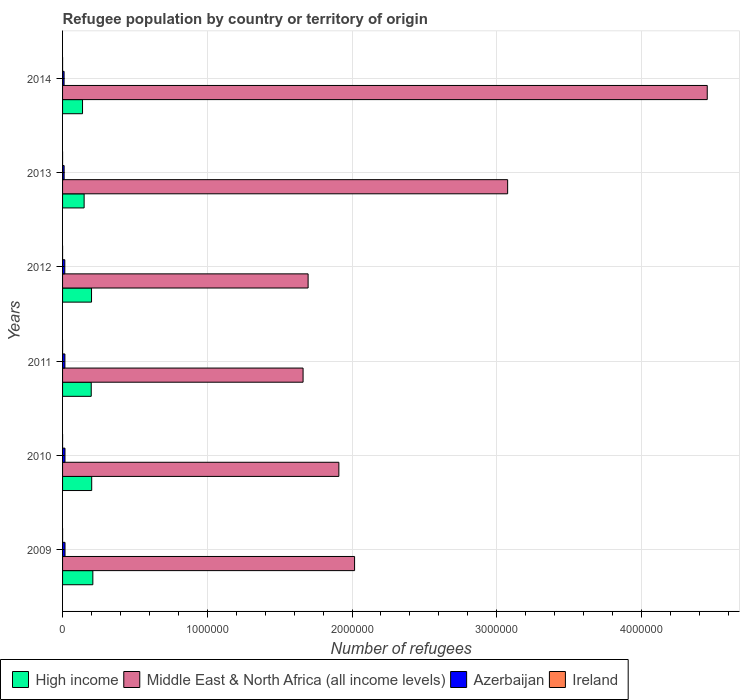Are the number of bars per tick equal to the number of legend labels?
Make the answer very short. Yes. What is the label of the 4th group of bars from the top?
Offer a terse response. 2011. In how many cases, is the number of bars for a given year not equal to the number of legend labels?
Give a very brief answer. 0. What is the number of refugees in Ireland in 2012?
Keep it short and to the point. 9. Across all years, what is the maximum number of refugees in Middle East & North Africa (all income levels)?
Offer a very short reply. 4.45e+06. Across all years, what is the minimum number of refugees in High income?
Provide a short and direct response. 1.38e+05. In which year was the number of refugees in Azerbaijan maximum?
Ensure brevity in your answer.  2009. In which year was the number of refugees in Middle East & North Africa (all income levels) minimum?
Make the answer very short. 2011. What is the total number of refugees in Middle East & North Africa (all income levels) in the graph?
Keep it short and to the point. 1.48e+07. What is the difference between the number of refugees in Azerbaijan in 2009 and that in 2014?
Keep it short and to the point. 6418. What is the difference between the number of refugees in High income in 2011 and the number of refugees in Middle East & North Africa (all income levels) in 2014?
Give a very brief answer. -4.26e+06. What is the average number of refugees in Middle East & North Africa (all income levels) per year?
Make the answer very short. 2.47e+06. In the year 2012, what is the difference between the number of refugees in Ireland and number of refugees in Azerbaijan?
Offer a very short reply. -1.55e+04. What is the ratio of the number of refugees in Middle East & North Africa (all income levels) in 2009 to that in 2014?
Your answer should be compact. 0.45. Is the number of refugees in Ireland in 2010 less than that in 2011?
Give a very brief answer. No. Is the difference between the number of refugees in Ireland in 2011 and 2012 greater than the difference between the number of refugees in Azerbaijan in 2011 and 2012?
Provide a short and direct response. No. What is the difference between the highest and the second highest number of refugees in High income?
Give a very brief answer. 7903. What is the difference between the highest and the lowest number of refugees in Middle East & North Africa (all income levels)?
Offer a terse response. 2.79e+06. Is it the case that in every year, the sum of the number of refugees in Middle East & North Africa (all income levels) and number of refugees in Ireland is greater than the sum of number of refugees in Azerbaijan and number of refugees in High income?
Offer a terse response. Yes. What does the 1st bar from the top in 2011 represents?
Provide a succinct answer. Ireland. What does the 1st bar from the bottom in 2009 represents?
Your answer should be very brief. High income. How many years are there in the graph?
Offer a very short reply. 6. Are the values on the major ticks of X-axis written in scientific E-notation?
Offer a terse response. No. Does the graph contain any zero values?
Provide a short and direct response. No. Does the graph contain grids?
Make the answer very short. Yes. How are the legend labels stacked?
Offer a very short reply. Horizontal. What is the title of the graph?
Give a very brief answer. Refugee population by country or territory of origin. What is the label or title of the X-axis?
Your answer should be compact. Number of refugees. What is the Number of refugees of High income in 2009?
Make the answer very short. 2.09e+05. What is the Number of refugees of Middle East & North Africa (all income levels) in 2009?
Make the answer very short. 2.02e+06. What is the Number of refugees in Azerbaijan in 2009?
Provide a short and direct response. 1.69e+04. What is the Number of refugees in High income in 2010?
Your response must be concise. 2.01e+05. What is the Number of refugees of Middle East & North Africa (all income levels) in 2010?
Provide a short and direct response. 1.91e+06. What is the Number of refugees in Azerbaijan in 2010?
Provide a short and direct response. 1.68e+04. What is the Number of refugees in Ireland in 2010?
Provide a succinct answer. 8. What is the Number of refugees in High income in 2011?
Your response must be concise. 1.98e+05. What is the Number of refugees in Middle East & North Africa (all income levels) in 2011?
Offer a terse response. 1.66e+06. What is the Number of refugees of Azerbaijan in 2011?
Make the answer very short. 1.62e+04. What is the Number of refugees in High income in 2012?
Offer a very short reply. 2.00e+05. What is the Number of refugees of Middle East & North Africa (all income levels) in 2012?
Your response must be concise. 1.70e+06. What is the Number of refugees in Azerbaijan in 2012?
Make the answer very short. 1.55e+04. What is the Number of refugees in Ireland in 2012?
Offer a terse response. 9. What is the Number of refugees of High income in 2013?
Offer a very short reply. 1.49e+05. What is the Number of refugees in Middle East & North Africa (all income levels) in 2013?
Give a very brief answer. 3.08e+06. What is the Number of refugees of Azerbaijan in 2013?
Offer a terse response. 1.08e+04. What is the Number of refugees in Ireland in 2013?
Keep it short and to the point. 9. What is the Number of refugees of High income in 2014?
Your answer should be compact. 1.38e+05. What is the Number of refugees in Middle East & North Africa (all income levels) in 2014?
Your answer should be very brief. 4.45e+06. What is the Number of refugees of Azerbaijan in 2014?
Provide a succinct answer. 1.05e+04. What is the Number of refugees of Ireland in 2014?
Offer a very short reply. 10. Across all years, what is the maximum Number of refugees of High income?
Make the answer very short. 2.09e+05. Across all years, what is the maximum Number of refugees of Middle East & North Africa (all income levels)?
Your answer should be very brief. 4.45e+06. Across all years, what is the maximum Number of refugees in Azerbaijan?
Keep it short and to the point. 1.69e+04. Across all years, what is the minimum Number of refugees in High income?
Give a very brief answer. 1.38e+05. Across all years, what is the minimum Number of refugees of Middle East & North Africa (all income levels)?
Offer a very short reply. 1.66e+06. Across all years, what is the minimum Number of refugees in Azerbaijan?
Your answer should be compact. 1.05e+04. Across all years, what is the minimum Number of refugees of Ireland?
Offer a very short reply. 7. What is the total Number of refugees in High income in the graph?
Provide a succinct answer. 1.10e+06. What is the total Number of refugees in Middle East & North Africa (all income levels) in the graph?
Your response must be concise. 1.48e+07. What is the total Number of refugees in Azerbaijan in the graph?
Your answer should be compact. 8.67e+04. What is the difference between the Number of refugees in High income in 2009 and that in 2010?
Give a very brief answer. 7903. What is the difference between the Number of refugees of Middle East & North Africa (all income levels) in 2009 and that in 2010?
Your response must be concise. 1.09e+05. What is the difference between the Number of refugees of Azerbaijan in 2009 and that in 2010?
Your response must be concise. 186. What is the difference between the Number of refugees of High income in 2009 and that in 2011?
Ensure brevity in your answer.  1.12e+04. What is the difference between the Number of refugees of Middle East & North Africa (all income levels) in 2009 and that in 2011?
Your response must be concise. 3.56e+05. What is the difference between the Number of refugees of Azerbaijan in 2009 and that in 2011?
Ensure brevity in your answer.  777. What is the difference between the Number of refugees of High income in 2009 and that in 2012?
Give a very brief answer. 9070. What is the difference between the Number of refugees of Middle East & North Africa (all income levels) in 2009 and that in 2012?
Give a very brief answer. 3.21e+05. What is the difference between the Number of refugees in Azerbaijan in 2009 and that in 2012?
Ensure brevity in your answer.  1402. What is the difference between the Number of refugees of High income in 2009 and that in 2013?
Your answer should be very brief. 6.02e+04. What is the difference between the Number of refugees in Middle East & North Africa (all income levels) in 2009 and that in 2013?
Your response must be concise. -1.06e+06. What is the difference between the Number of refugees of Azerbaijan in 2009 and that in 2013?
Provide a short and direct response. 6126. What is the difference between the Number of refugees in Ireland in 2009 and that in 2013?
Provide a succinct answer. -2. What is the difference between the Number of refugees of High income in 2009 and that in 2014?
Ensure brevity in your answer.  7.13e+04. What is the difference between the Number of refugees in Middle East & North Africa (all income levels) in 2009 and that in 2014?
Your answer should be very brief. -2.44e+06. What is the difference between the Number of refugees of Azerbaijan in 2009 and that in 2014?
Provide a short and direct response. 6418. What is the difference between the Number of refugees of High income in 2010 and that in 2011?
Make the answer very short. 3264. What is the difference between the Number of refugees in Middle East & North Africa (all income levels) in 2010 and that in 2011?
Provide a succinct answer. 2.47e+05. What is the difference between the Number of refugees of Azerbaijan in 2010 and that in 2011?
Make the answer very short. 591. What is the difference between the Number of refugees of High income in 2010 and that in 2012?
Your response must be concise. 1167. What is the difference between the Number of refugees of Middle East & North Africa (all income levels) in 2010 and that in 2012?
Make the answer very short. 2.12e+05. What is the difference between the Number of refugees in Azerbaijan in 2010 and that in 2012?
Provide a short and direct response. 1216. What is the difference between the Number of refugees of Ireland in 2010 and that in 2012?
Keep it short and to the point. -1. What is the difference between the Number of refugees in High income in 2010 and that in 2013?
Your answer should be very brief. 5.23e+04. What is the difference between the Number of refugees in Middle East & North Africa (all income levels) in 2010 and that in 2013?
Offer a terse response. -1.17e+06. What is the difference between the Number of refugees of Azerbaijan in 2010 and that in 2013?
Your response must be concise. 5940. What is the difference between the Number of refugees in Ireland in 2010 and that in 2013?
Ensure brevity in your answer.  -1. What is the difference between the Number of refugees in High income in 2010 and that in 2014?
Provide a short and direct response. 6.34e+04. What is the difference between the Number of refugees of Middle East & North Africa (all income levels) in 2010 and that in 2014?
Give a very brief answer. -2.55e+06. What is the difference between the Number of refugees of Azerbaijan in 2010 and that in 2014?
Your answer should be compact. 6232. What is the difference between the Number of refugees of Ireland in 2010 and that in 2014?
Give a very brief answer. -2. What is the difference between the Number of refugees in High income in 2011 and that in 2012?
Offer a very short reply. -2097. What is the difference between the Number of refugees of Middle East & North Africa (all income levels) in 2011 and that in 2012?
Make the answer very short. -3.48e+04. What is the difference between the Number of refugees of Azerbaijan in 2011 and that in 2012?
Provide a succinct answer. 625. What is the difference between the Number of refugees in Ireland in 2011 and that in 2012?
Your response must be concise. -1. What is the difference between the Number of refugees of High income in 2011 and that in 2013?
Offer a terse response. 4.90e+04. What is the difference between the Number of refugees in Middle East & North Africa (all income levels) in 2011 and that in 2013?
Your answer should be very brief. -1.41e+06. What is the difference between the Number of refugees in Azerbaijan in 2011 and that in 2013?
Provide a short and direct response. 5349. What is the difference between the Number of refugees in High income in 2011 and that in 2014?
Your answer should be very brief. 6.01e+04. What is the difference between the Number of refugees of Middle East & North Africa (all income levels) in 2011 and that in 2014?
Make the answer very short. -2.79e+06. What is the difference between the Number of refugees in Azerbaijan in 2011 and that in 2014?
Ensure brevity in your answer.  5641. What is the difference between the Number of refugees of High income in 2012 and that in 2013?
Offer a very short reply. 5.11e+04. What is the difference between the Number of refugees in Middle East & North Africa (all income levels) in 2012 and that in 2013?
Provide a short and direct response. -1.38e+06. What is the difference between the Number of refugees of Azerbaijan in 2012 and that in 2013?
Keep it short and to the point. 4724. What is the difference between the Number of refugees in Ireland in 2012 and that in 2013?
Keep it short and to the point. 0. What is the difference between the Number of refugees of High income in 2012 and that in 2014?
Make the answer very short. 6.22e+04. What is the difference between the Number of refugees in Middle East & North Africa (all income levels) in 2012 and that in 2014?
Ensure brevity in your answer.  -2.76e+06. What is the difference between the Number of refugees of Azerbaijan in 2012 and that in 2014?
Offer a terse response. 5016. What is the difference between the Number of refugees of High income in 2013 and that in 2014?
Your answer should be very brief. 1.11e+04. What is the difference between the Number of refugees in Middle East & North Africa (all income levels) in 2013 and that in 2014?
Keep it short and to the point. -1.38e+06. What is the difference between the Number of refugees in Azerbaijan in 2013 and that in 2014?
Your response must be concise. 292. What is the difference between the Number of refugees of Ireland in 2013 and that in 2014?
Your response must be concise. -1. What is the difference between the Number of refugees of High income in 2009 and the Number of refugees of Middle East & North Africa (all income levels) in 2010?
Your response must be concise. -1.70e+06. What is the difference between the Number of refugees in High income in 2009 and the Number of refugees in Azerbaijan in 2010?
Provide a short and direct response. 1.92e+05. What is the difference between the Number of refugees of High income in 2009 and the Number of refugees of Ireland in 2010?
Your answer should be very brief. 2.09e+05. What is the difference between the Number of refugees of Middle East & North Africa (all income levels) in 2009 and the Number of refugees of Azerbaijan in 2010?
Offer a terse response. 2.00e+06. What is the difference between the Number of refugees in Middle East & North Africa (all income levels) in 2009 and the Number of refugees in Ireland in 2010?
Your answer should be compact. 2.02e+06. What is the difference between the Number of refugees of Azerbaijan in 2009 and the Number of refugees of Ireland in 2010?
Give a very brief answer. 1.69e+04. What is the difference between the Number of refugees in High income in 2009 and the Number of refugees in Middle East & North Africa (all income levels) in 2011?
Your answer should be very brief. -1.45e+06. What is the difference between the Number of refugees of High income in 2009 and the Number of refugees of Azerbaijan in 2011?
Offer a very short reply. 1.93e+05. What is the difference between the Number of refugees in High income in 2009 and the Number of refugees in Ireland in 2011?
Keep it short and to the point. 2.09e+05. What is the difference between the Number of refugees in Middle East & North Africa (all income levels) in 2009 and the Number of refugees in Azerbaijan in 2011?
Provide a succinct answer. 2.00e+06. What is the difference between the Number of refugees of Middle East & North Africa (all income levels) in 2009 and the Number of refugees of Ireland in 2011?
Provide a succinct answer. 2.02e+06. What is the difference between the Number of refugees of Azerbaijan in 2009 and the Number of refugees of Ireland in 2011?
Your answer should be compact. 1.69e+04. What is the difference between the Number of refugees of High income in 2009 and the Number of refugees of Middle East & North Africa (all income levels) in 2012?
Provide a succinct answer. -1.49e+06. What is the difference between the Number of refugees of High income in 2009 and the Number of refugees of Azerbaijan in 2012?
Ensure brevity in your answer.  1.94e+05. What is the difference between the Number of refugees in High income in 2009 and the Number of refugees in Ireland in 2012?
Your answer should be very brief. 2.09e+05. What is the difference between the Number of refugees in Middle East & North Africa (all income levels) in 2009 and the Number of refugees in Azerbaijan in 2012?
Keep it short and to the point. 2.00e+06. What is the difference between the Number of refugees in Middle East & North Africa (all income levels) in 2009 and the Number of refugees in Ireland in 2012?
Your response must be concise. 2.02e+06. What is the difference between the Number of refugees in Azerbaijan in 2009 and the Number of refugees in Ireland in 2012?
Make the answer very short. 1.69e+04. What is the difference between the Number of refugees in High income in 2009 and the Number of refugees in Middle East & North Africa (all income levels) in 2013?
Offer a very short reply. -2.87e+06. What is the difference between the Number of refugees in High income in 2009 and the Number of refugees in Azerbaijan in 2013?
Your answer should be very brief. 1.98e+05. What is the difference between the Number of refugees of High income in 2009 and the Number of refugees of Ireland in 2013?
Offer a very short reply. 2.09e+05. What is the difference between the Number of refugees in Middle East & North Africa (all income levels) in 2009 and the Number of refugees in Azerbaijan in 2013?
Ensure brevity in your answer.  2.01e+06. What is the difference between the Number of refugees in Middle East & North Africa (all income levels) in 2009 and the Number of refugees in Ireland in 2013?
Provide a short and direct response. 2.02e+06. What is the difference between the Number of refugees of Azerbaijan in 2009 and the Number of refugees of Ireland in 2013?
Ensure brevity in your answer.  1.69e+04. What is the difference between the Number of refugees in High income in 2009 and the Number of refugees in Middle East & North Africa (all income levels) in 2014?
Your answer should be compact. -4.25e+06. What is the difference between the Number of refugees in High income in 2009 and the Number of refugees in Azerbaijan in 2014?
Offer a very short reply. 1.99e+05. What is the difference between the Number of refugees of High income in 2009 and the Number of refugees of Ireland in 2014?
Your response must be concise. 2.09e+05. What is the difference between the Number of refugees in Middle East & North Africa (all income levels) in 2009 and the Number of refugees in Azerbaijan in 2014?
Keep it short and to the point. 2.01e+06. What is the difference between the Number of refugees in Middle East & North Africa (all income levels) in 2009 and the Number of refugees in Ireland in 2014?
Keep it short and to the point. 2.02e+06. What is the difference between the Number of refugees in Azerbaijan in 2009 and the Number of refugees in Ireland in 2014?
Your answer should be compact. 1.69e+04. What is the difference between the Number of refugees in High income in 2010 and the Number of refugees in Middle East & North Africa (all income levels) in 2011?
Provide a succinct answer. -1.46e+06. What is the difference between the Number of refugees in High income in 2010 and the Number of refugees in Azerbaijan in 2011?
Provide a succinct answer. 1.85e+05. What is the difference between the Number of refugees in High income in 2010 and the Number of refugees in Ireland in 2011?
Your answer should be compact. 2.01e+05. What is the difference between the Number of refugees of Middle East & North Africa (all income levels) in 2010 and the Number of refugees of Azerbaijan in 2011?
Make the answer very short. 1.89e+06. What is the difference between the Number of refugees of Middle East & North Africa (all income levels) in 2010 and the Number of refugees of Ireland in 2011?
Your answer should be very brief. 1.91e+06. What is the difference between the Number of refugees in Azerbaijan in 2010 and the Number of refugees in Ireland in 2011?
Provide a succinct answer. 1.67e+04. What is the difference between the Number of refugees of High income in 2010 and the Number of refugees of Middle East & North Africa (all income levels) in 2012?
Your answer should be compact. -1.50e+06. What is the difference between the Number of refugees in High income in 2010 and the Number of refugees in Azerbaijan in 2012?
Your answer should be very brief. 1.86e+05. What is the difference between the Number of refugees of High income in 2010 and the Number of refugees of Ireland in 2012?
Give a very brief answer. 2.01e+05. What is the difference between the Number of refugees of Middle East & North Africa (all income levels) in 2010 and the Number of refugees of Azerbaijan in 2012?
Offer a terse response. 1.89e+06. What is the difference between the Number of refugees of Middle East & North Africa (all income levels) in 2010 and the Number of refugees of Ireland in 2012?
Ensure brevity in your answer.  1.91e+06. What is the difference between the Number of refugees of Azerbaijan in 2010 and the Number of refugees of Ireland in 2012?
Offer a very short reply. 1.67e+04. What is the difference between the Number of refugees in High income in 2010 and the Number of refugees in Middle East & North Africa (all income levels) in 2013?
Your answer should be very brief. -2.87e+06. What is the difference between the Number of refugees of High income in 2010 and the Number of refugees of Azerbaijan in 2013?
Your response must be concise. 1.90e+05. What is the difference between the Number of refugees in High income in 2010 and the Number of refugees in Ireland in 2013?
Ensure brevity in your answer.  2.01e+05. What is the difference between the Number of refugees in Middle East & North Africa (all income levels) in 2010 and the Number of refugees in Azerbaijan in 2013?
Your response must be concise. 1.90e+06. What is the difference between the Number of refugees in Middle East & North Africa (all income levels) in 2010 and the Number of refugees in Ireland in 2013?
Offer a very short reply. 1.91e+06. What is the difference between the Number of refugees of Azerbaijan in 2010 and the Number of refugees of Ireland in 2013?
Your answer should be compact. 1.67e+04. What is the difference between the Number of refugees in High income in 2010 and the Number of refugees in Middle East & North Africa (all income levels) in 2014?
Provide a succinct answer. -4.25e+06. What is the difference between the Number of refugees of High income in 2010 and the Number of refugees of Azerbaijan in 2014?
Ensure brevity in your answer.  1.91e+05. What is the difference between the Number of refugees in High income in 2010 and the Number of refugees in Ireland in 2014?
Provide a succinct answer. 2.01e+05. What is the difference between the Number of refugees in Middle East & North Africa (all income levels) in 2010 and the Number of refugees in Azerbaijan in 2014?
Your answer should be compact. 1.90e+06. What is the difference between the Number of refugees of Middle East & North Africa (all income levels) in 2010 and the Number of refugees of Ireland in 2014?
Ensure brevity in your answer.  1.91e+06. What is the difference between the Number of refugees in Azerbaijan in 2010 and the Number of refugees in Ireland in 2014?
Your response must be concise. 1.67e+04. What is the difference between the Number of refugees of High income in 2011 and the Number of refugees of Middle East & North Africa (all income levels) in 2012?
Give a very brief answer. -1.50e+06. What is the difference between the Number of refugees of High income in 2011 and the Number of refugees of Azerbaijan in 2012?
Offer a very short reply. 1.82e+05. What is the difference between the Number of refugees in High income in 2011 and the Number of refugees in Ireland in 2012?
Your answer should be very brief. 1.98e+05. What is the difference between the Number of refugees of Middle East & North Africa (all income levels) in 2011 and the Number of refugees of Azerbaijan in 2012?
Offer a very short reply. 1.65e+06. What is the difference between the Number of refugees in Middle East & North Africa (all income levels) in 2011 and the Number of refugees in Ireland in 2012?
Your answer should be compact. 1.66e+06. What is the difference between the Number of refugees of Azerbaijan in 2011 and the Number of refugees of Ireland in 2012?
Keep it short and to the point. 1.62e+04. What is the difference between the Number of refugees in High income in 2011 and the Number of refugees in Middle East & North Africa (all income levels) in 2013?
Ensure brevity in your answer.  -2.88e+06. What is the difference between the Number of refugees of High income in 2011 and the Number of refugees of Azerbaijan in 2013?
Keep it short and to the point. 1.87e+05. What is the difference between the Number of refugees of High income in 2011 and the Number of refugees of Ireland in 2013?
Make the answer very short. 1.98e+05. What is the difference between the Number of refugees in Middle East & North Africa (all income levels) in 2011 and the Number of refugees in Azerbaijan in 2013?
Offer a terse response. 1.65e+06. What is the difference between the Number of refugees of Middle East & North Africa (all income levels) in 2011 and the Number of refugees of Ireland in 2013?
Provide a succinct answer. 1.66e+06. What is the difference between the Number of refugees of Azerbaijan in 2011 and the Number of refugees of Ireland in 2013?
Ensure brevity in your answer.  1.62e+04. What is the difference between the Number of refugees of High income in 2011 and the Number of refugees of Middle East & North Africa (all income levels) in 2014?
Ensure brevity in your answer.  -4.26e+06. What is the difference between the Number of refugees in High income in 2011 and the Number of refugees in Azerbaijan in 2014?
Make the answer very short. 1.88e+05. What is the difference between the Number of refugees of High income in 2011 and the Number of refugees of Ireland in 2014?
Give a very brief answer. 1.98e+05. What is the difference between the Number of refugees in Middle East & North Africa (all income levels) in 2011 and the Number of refugees in Azerbaijan in 2014?
Ensure brevity in your answer.  1.65e+06. What is the difference between the Number of refugees of Middle East & North Africa (all income levels) in 2011 and the Number of refugees of Ireland in 2014?
Your answer should be very brief. 1.66e+06. What is the difference between the Number of refugees in Azerbaijan in 2011 and the Number of refugees in Ireland in 2014?
Make the answer very short. 1.62e+04. What is the difference between the Number of refugees of High income in 2012 and the Number of refugees of Middle East & North Africa (all income levels) in 2013?
Give a very brief answer. -2.87e+06. What is the difference between the Number of refugees in High income in 2012 and the Number of refugees in Azerbaijan in 2013?
Keep it short and to the point. 1.89e+05. What is the difference between the Number of refugees in High income in 2012 and the Number of refugees in Ireland in 2013?
Offer a terse response. 2.00e+05. What is the difference between the Number of refugees in Middle East & North Africa (all income levels) in 2012 and the Number of refugees in Azerbaijan in 2013?
Offer a very short reply. 1.69e+06. What is the difference between the Number of refugees in Middle East & North Africa (all income levels) in 2012 and the Number of refugees in Ireland in 2013?
Make the answer very short. 1.70e+06. What is the difference between the Number of refugees in Azerbaijan in 2012 and the Number of refugees in Ireland in 2013?
Offer a very short reply. 1.55e+04. What is the difference between the Number of refugees in High income in 2012 and the Number of refugees in Middle East & North Africa (all income levels) in 2014?
Give a very brief answer. -4.25e+06. What is the difference between the Number of refugees in High income in 2012 and the Number of refugees in Azerbaijan in 2014?
Give a very brief answer. 1.90e+05. What is the difference between the Number of refugees of High income in 2012 and the Number of refugees of Ireland in 2014?
Provide a succinct answer. 2.00e+05. What is the difference between the Number of refugees of Middle East & North Africa (all income levels) in 2012 and the Number of refugees of Azerbaijan in 2014?
Your answer should be very brief. 1.69e+06. What is the difference between the Number of refugees in Middle East & North Africa (all income levels) in 2012 and the Number of refugees in Ireland in 2014?
Offer a very short reply. 1.70e+06. What is the difference between the Number of refugees of Azerbaijan in 2012 and the Number of refugees of Ireland in 2014?
Ensure brevity in your answer.  1.55e+04. What is the difference between the Number of refugees of High income in 2013 and the Number of refugees of Middle East & North Africa (all income levels) in 2014?
Offer a terse response. -4.31e+06. What is the difference between the Number of refugees of High income in 2013 and the Number of refugees of Azerbaijan in 2014?
Ensure brevity in your answer.  1.38e+05. What is the difference between the Number of refugees in High income in 2013 and the Number of refugees in Ireland in 2014?
Your response must be concise. 1.49e+05. What is the difference between the Number of refugees of Middle East & North Africa (all income levels) in 2013 and the Number of refugees of Azerbaijan in 2014?
Offer a very short reply. 3.06e+06. What is the difference between the Number of refugees in Middle East & North Africa (all income levels) in 2013 and the Number of refugees in Ireland in 2014?
Ensure brevity in your answer.  3.08e+06. What is the difference between the Number of refugees in Azerbaijan in 2013 and the Number of refugees in Ireland in 2014?
Give a very brief answer. 1.08e+04. What is the average Number of refugees in High income per year?
Your answer should be compact. 1.83e+05. What is the average Number of refugees of Middle East & North Africa (all income levels) per year?
Your answer should be compact. 2.47e+06. What is the average Number of refugees of Azerbaijan per year?
Your answer should be compact. 1.45e+04. In the year 2009, what is the difference between the Number of refugees in High income and Number of refugees in Middle East & North Africa (all income levels)?
Offer a terse response. -1.81e+06. In the year 2009, what is the difference between the Number of refugees in High income and Number of refugees in Azerbaijan?
Offer a very short reply. 1.92e+05. In the year 2009, what is the difference between the Number of refugees in High income and Number of refugees in Ireland?
Your answer should be very brief. 2.09e+05. In the year 2009, what is the difference between the Number of refugees in Middle East & North Africa (all income levels) and Number of refugees in Azerbaijan?
Provide a short and direct response. 2.00e+06. In the year 2009, what is the difference between the Number of refugees in Middle East & North Africa (all income levels) and Number of refugees in Ireland?
Your answer should be very brief. 2.02e+06. In the year 2009, what is the difference between the Number of refugees of Azerbaijan and Number of refugees of Ireland?
Your response must be concise. 1.69e+04. In the year 2010, what is the difference between the Number of refugees in High income and Number of refugees in Middle East & North Africa (all income levels)?
Provide a succinct answer. -1.71e+06. In the year 2010, what is the difference between the Number of refugees of High income and Number of refugees of Azerbaijan?
Provide a short and direct response. 1.85e+05. In the year 2010, what is the difference between the Number of refugees of High income and Number of refugees of Ireland?
Make the answer very short. 2.01e+05. In the year 2010, what is the difference between the Number of refugees of Middle East & North Africa (all income levels) and Number of refugees of Azerbaijan?
Your answer should be compact. 1.89e+06. In the year 2010, what is the difference between the Number of refugees in Middle East & North Africa (all income levels) and Number of refugees in Ireland?
Your answer should be compact. 1.91e+06. In the year 2010, what is the difference between the Number of refugees in Azerbaijan and Number of refugees in Ireland?
Offer a very short reply. 1.67e+04. In the year 2011, what is the difference between the Number of refugees of High income and Number of refugees of Middle East & North Africa (all income levels)?
Your answer should be very brief. -1.46e+06. In the year 2011, what is the difference between the Number of refugees in High income and Number of refugees in Azerbaijan?
Make the answer very short. 1.82e+05. In the year 2011, what is the difference between the Number of refugees of High income and Number of refugees of Ireland?
Keep it short and to the point. 1.98e+05. In the year 2011, what is the difference between the Number of refugees in Middle East & North Africa (all income levels) and Number of refugees in Azerbaijan?
Give a very brief answer. 1.65e+06. In the year 2011, what is the difference between the Number of refugees in Middle East & North Africa (all income levels) and Number of refugees in Ireland?
Give a very brief answer. 1.66e+06. In the year 2011, what is the difference between the Number of refugees in Azerbaijan and Number of refugees in Ireland?
Your answer should be very brief. 1.62e+04. In the year 2012, what is the difference between the Number of refugees of High income and Number of refugees of Middle East & North Africa (all income levels)?
Ensure brevity in your answer.  -1.50e+06. In the year 2012, what is the difference between the Number of refugees in High income and Number of refugees in Azerbaijan?
Make the answer very short. 1.85e+05. In the year 2012, what is the difference between the Number of refugees in High income and Number of refugees in Ireland?
Your response must be concise. 2.00e+05. In the year 2012, what is the difference between the Number of refugees in Middle East & North Africa (all income levels) and Number of refugees in Azerbaijan?
Offer a very short reply. 1.68e+06. In the year 2012, what is the difference between the Number of refugees in Middle East & North Africa (all income levels) and Number of refugees in Ireland?
Your response must be concise. 1.70e+06. In the year 2012, what is the difference between the Number of refugees of Azerbaijan and Number of refugees of Ireland?
Your response must be concise. 1.55e+04. In the year 2013, what is the difference between the Number of refugees in High income and Number of refugees in Middle East & North Africa (all income levels)?
Your response must be concise. -2.93e+06. In the year 2013, what is the difference between the Number of refugees in High income and Number of refugees in Azerbaijan?
Offer a terse response. 1.38e+05. In the year 2013, what is the difference between the Number of refugees in High income and Number of refugees in Ireland?
Give a very brief answer. 1.49e+05. In the year 2013, what is the difference between the Number of refugees in Middle East & North Africa (all income levels) and Number of refugees in Azerbaijan?
Your response must be concise. 3.06e+06. In the year 2013, what is the difference between the Number of refugees of Middle East & North Africa (all income levels) and Number of refugees of Ireland?
Provide a succinct answer. 3.08e+06. In the year 2013, what is the difference between the Number of refugees in Azerbaijan and Number of refugees in Ireland?
Your answer should be very brief. 1.08e+04. In the year 2014, what is the difference between the Number of refugees of High income and Number of refugees of Middle East & North Africa (all income levels)?
Offer a terse response. -4.32e+06. In the year 2014, what is the difference between the Number of refugees in High income and Number of refugees in Azerbaijan?
Ensure brevity in your answer.  1.27e+05. In the year 2014, what is the difference between the Number of refugees in High income and Number of refugees in Ireland?
Offer a very short reply. 1.38e+05. In the year 2014, what is the difference between the Number of refugees of Middle East & North Africa (all income levels) and Number of refugees of Azerbaijan?
Your answer should be very brief. 4.44e+06. In the year 2014, what is the difference between the Number of refugees in Middle East & North Africa (all income levels) and Number of refugees in Ireland?
Your response must be concise. 4.45e+06. In the year 2014, what is the difference between the Number of refugees in Azerbaijan and Number of refugees in Ireland?
Keep it short and to the point. 1.05e+04. What is the ratio of the Number of refugees in High income in 2009 to that in 2010?
Ensure brevity in your answer.  1.04. What is the ratio of the Number of refugees in Middle East & North Africa (all income levels) in 2009 to that in 2010?
Offer a terse response. 1.06. What is the ratio of the Number of refugees in Azerbaijan in 2009 to that in 2010?
Make the answer very short. 1.01. What is the ratio of the Number of refugees in Ireland in 2009 to that in 2010?
Your answer should be very brief. 0.88. What is the ratio of the Number of refugees in High income in 2009 to that in 2011?
Your response must be concise. 1.06. What is the ratio of the Number of refugees of Middle East & North Africa (all income levels) in 2009 to that in 2011?
Your answer should be very brief. 1.21. What is the ratio of the Number of refugees in Azerbaijan in 2009 to that in 2011?
Offer a terse response. 1.05. What is the ratio of the Number of refugees of High income in 2009 to that in 2012?
Provide a short and direct response. 1.05. What is the ratio of the Number of refugees in Middle East & North Africa (all income levels) in 2009 to that in 2012?
Your answer should be compact. 1.19. What is the ratio of the Number of refugees of Azerbaijan in 2009 to that in 2012?
Keep it short and to the point. 1.09. What is the ratio of the Number of refugees in Ireland in 2009 to that in 2012?
Keep it short and to the point. 0.78. What is the ratio of the Number of refugees of High income in 2009 to that in 2013?
Offer a terse response. 1.4. What is the ratio of the Number of refugees in Middle East & North Africa (all income levels) in 2009 to that in 2013?
Your response must be concise. 0.66. What is the ratio of the Number of refugees of Azerbaijan in 2009 to that in 2013?
Offer a very short reply. 1.57. What is the ratio of the Number of refugees in Ireland in 2009 to that in 2013?
Offer a very short reply. 0.78. What is the ratio of the Number of refugees of High income in 2009 to that in 2014?
Ensure brevity in your answer.  1.52. What is the ratio of the Number of refugees of Middle East & North Africa (all income levels) in 2009 to that in 2014?
Give a very brief answer. 0.45. What is the ratio of the Number of refugees in Azerbaijan in 2009 to that in 2014?
Ensure brevity in your answer.  1.61. What is the ratio of the Number of refugees of High income in 2010 to that in 2011?
Keep it short and to the point. 1.02. What is the ratio of the Number of refugees in Middle East & North Africa (all income levels) in 2010 to that in 2011?
Ensure brevity in your answer.  1.15. What is the ratio of the Number of refugees in Azerbaijan in 2010 to that in 2011?
Your answer should be very brief. 1.04. What is the ratio of the Number of refugees of Middle East & North Africa (all income levels) in 2010 to that in 2012?
Your answer should be compact. 1.13. What is the ratio of the Number of refugees of Azerbaijan in 2010 to that in 2012?
Make the answer very short. 1.08. What is the ratio of the Number of refugees of High income in 2010 to that in 2013?
Your response must be concise. 1.35. What is the ratio of the Number of refugees in Middle East & North Africa (all income levels) in 2010 to that in 2013?
Provide a succinct answer. 0.62. What is the ratio of the Number of refugees in Azerbaijan in 2010 to that in 2013?
Offer a terse response. 1.55. What is the ratio of the Number of refugees of Ireland in 2010 to that in 2013?
Ensure brevity in your answer.  0.89. What is the ratio of the Number of refugees of High income in 2010 to that in 2014?
Offer a terse response. 1.46. What is the ratio of the Number of refugees of Middle East & North Africa (all income levels) in 2010 to that in 2014?
Provide a short and direct response. 0.43. What is the ratio of the Number of refugees of Azerbaijan in 2010 to that in 2014?
Offer a very short reply. 1.59. What is the ratio of the Number of refugees in Middle East & North Africa (all income levels) in 2011 to that in 2012?
Your response must be concise. 0.98. What is the ratio of the Number of refugees in Azerbaijan in 2011 to that in 2012?
Offer a terse response. 1.04. What is the ratio of the Number of refugees of Ireland in 2011 to that in 2012?
Your answer should be compact. 0.89. What is the ratio of the Number of refugees in High income in 2011 to that in 2013?
Provide a succinct answer. 1.33. What is the ratio of the Number of refugees of Middle East & North Africa (all income levels) in 2011 to that in 2013?
Provide a succinct answer. 0.54. What is the ratio of the Number of refugees of Azerbaijan in 2011 to that in 2013?
Offer a very short reply. 1.49. What is the ratio of the Number of refugees in Ireland in 2011 to that in 2013?
Your answer should be compact. 0.89. What is the ratio of the Number of refugees in High income in 2011 to that in 2014?
Offer a terse response. 1.44. What is the ratio of the Number of refugees of Middle East & North Africa (all income levels) in 2011 to that in 2014?
Your response must be concise. 0.37. What is the ratio of the Number of refugees of Azerbaijan in 2011 to that in 2014?
Your response must be concise. 1.54. What is the ratio of the Number of refugees in Ireland in 2011 to that in 2014?
Your answer should be compact. 0.8. What is the ratio of the Number of refugees of High income in 2012 to that in 2013?
Offer a terse response. 1.34. What is the ratio of the Number of refugees of Middle East & North Africa (all income levels) in 2012 to that in 2013?
Give a very brief answer. 0.55. What is the ratio of the Number of refugees in Azerbaijan in 2012 to that in 2013?
Provide a short and direct response. 1.44. What is the ratio of the Number of refugees in Ireland in 2012 to that in 2013?
Make the answer very short. 1. What is the ratio of the Number of refugees of High income in 2012 to that in 2014?
Your answer should be compact. 1.45. What is the ratio of the Number of refugees of Middle East & North Africa (all income levels) in 2012 to that in 2014?
Your answer should be very brief. 0.38. What is the ratio of the Number of refugees in Azerbaijan in 2012 to that in 2014?
Keep it short and to the point. 1.48. What is the ratio of the Number of refugees of High income in 2013 to that in 2014?
Make the answer very short. 1.08. What is the ratio of the Number of refugees in Middle East & North Africa (all income levels) in 2013 to that in 2014?
Offer a terse response. 0.69. What is the ratio of the Number of refugees of Azerbaijan in 2013 to that in 2014?
Your response must be concise. 1.03. What is the ratio of the Number of refugees in Ireland in 2013 to that in 2014?
Make the answer very short. 0.9. What is the difference between the highest and the second highest Number of refugees of High income?
Give a very brief answer. 7903. What is the difference between the highest and the second highest Number of refugees in Middle East & North Africa (all income levels)?
Give a very brief answer. 1.38e+06. What is the difference between the highest and the second highest Number of refugees of Azerbaijan?
Make the answer very short. 186. What is the difference between the highest and the lowest Number of refugees in High income?
Your response must be concise. 7.13e+04. What is the difference between the highest and the lowest Number of refugees of Middle East & North Africa (all income levels)?
Provide a short and direct response. 2.79e+06. What is the difference between the highest and the lowest Number of refugees in Azerbaijan?
Your response must be concise. 6418. 